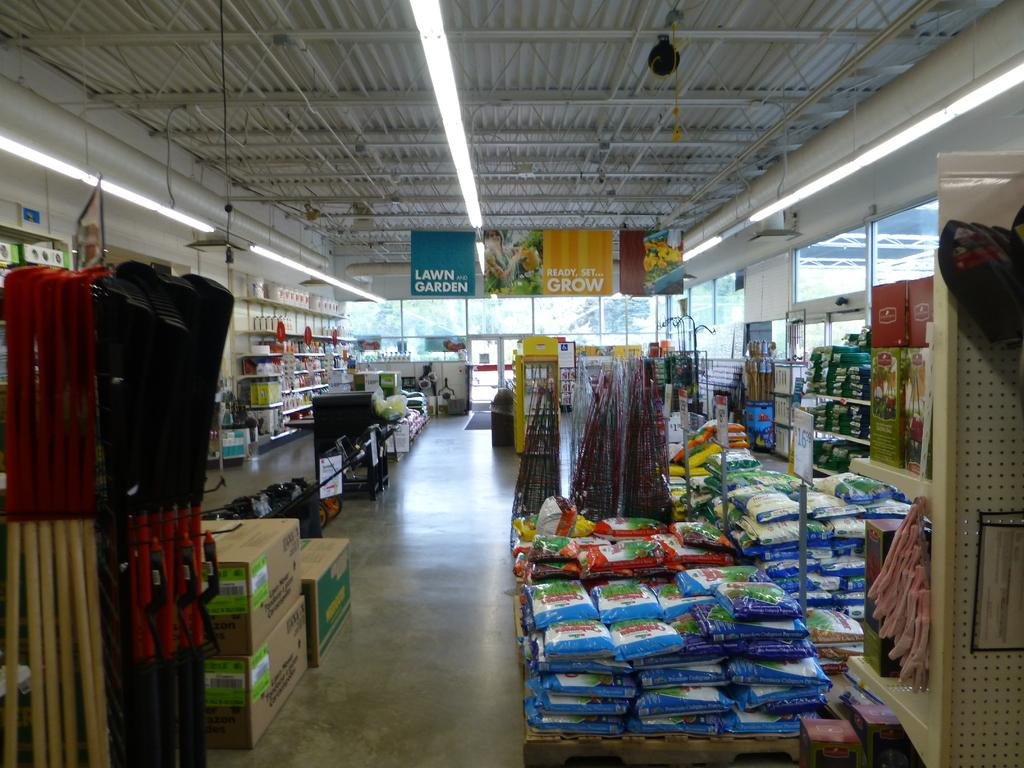<image>
Offer a succinct explanation of the picture presented. a sign above the ground that says ready, set, grow 